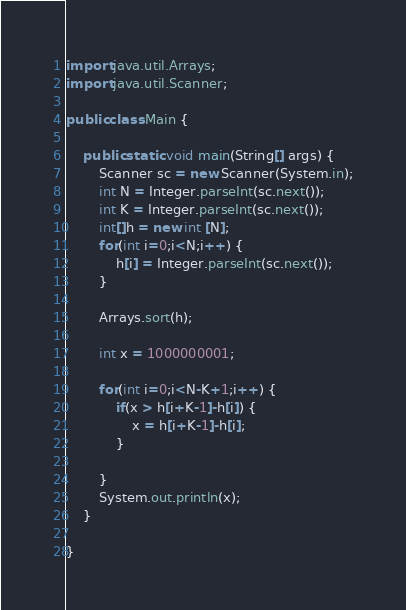Convert code to text. <code><loc_0><loc_0><loc_500><loc_500><_Java_>import java.util.Arrays;
import java.util.Scanner;

public class Main {

	public static void main(String[] args) {
		Scanner sc = new Scanner(System.in);
		int N = Integer.parseInt(sc.next());
		int K = Integer.parseInt(sc.next());
		int[]h = new int [N];
		for(int i=0;i<N;i++) {
			h[i] = Integer.parseInt(sc.next());
		}

		Arrays.sort(h);

		int x = 1000000001;

		for(int i=0;i<N-K+1;i++) {
			if(x > h[i+K-1]-h[i]) {
				x = h[i+K-1]-h[i];
			}

		}
		System.out.println(x);
	}

}
</code> 